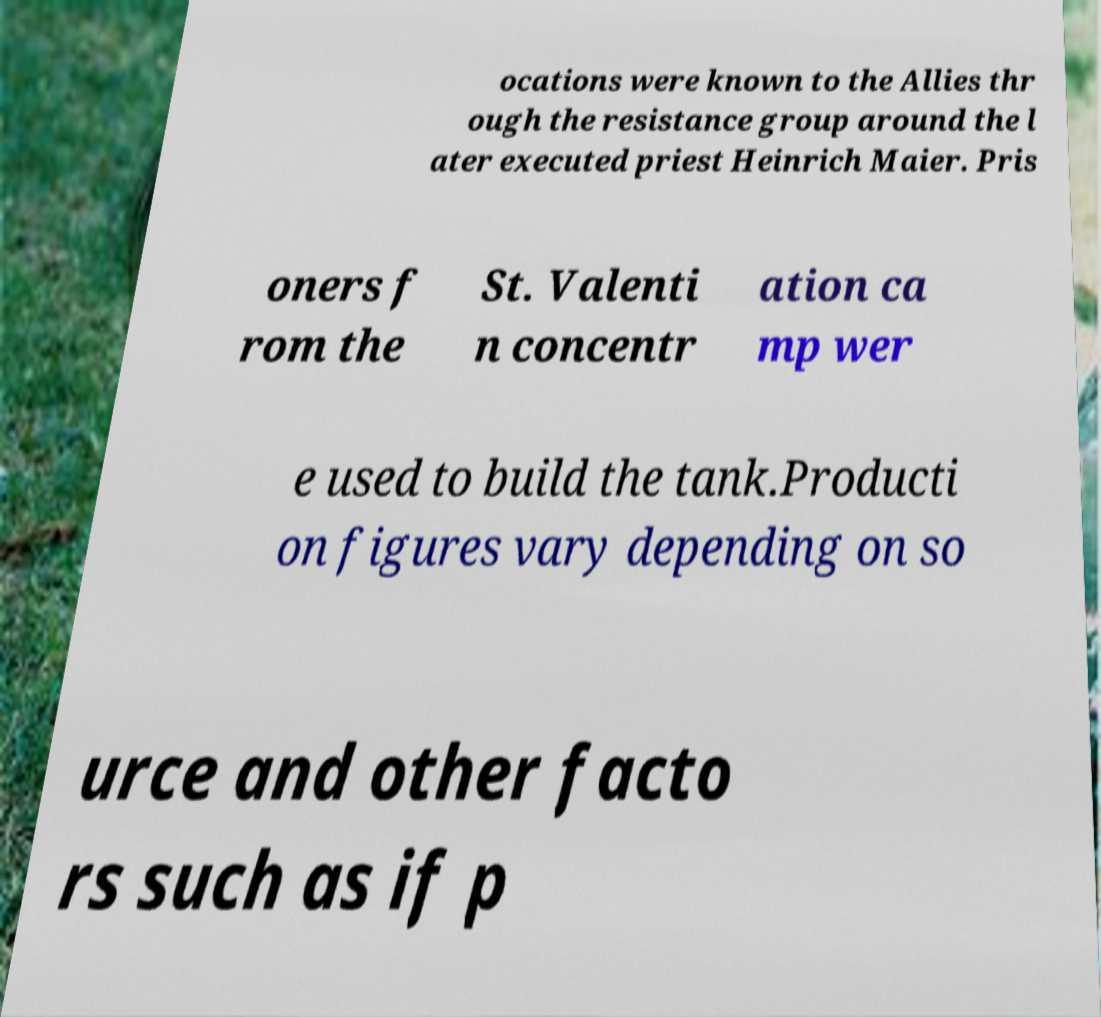Please identify and transcribe the text found in this image. ocations were known to the Allies thr ough the resistance group around the l ater executed priest Heinrich Maier. Pris oners f rom the St. Valenti n concentr ation ca mp wer e used to build the tank.Producti on figures vary depending on so urce and other facto rs such as if p 